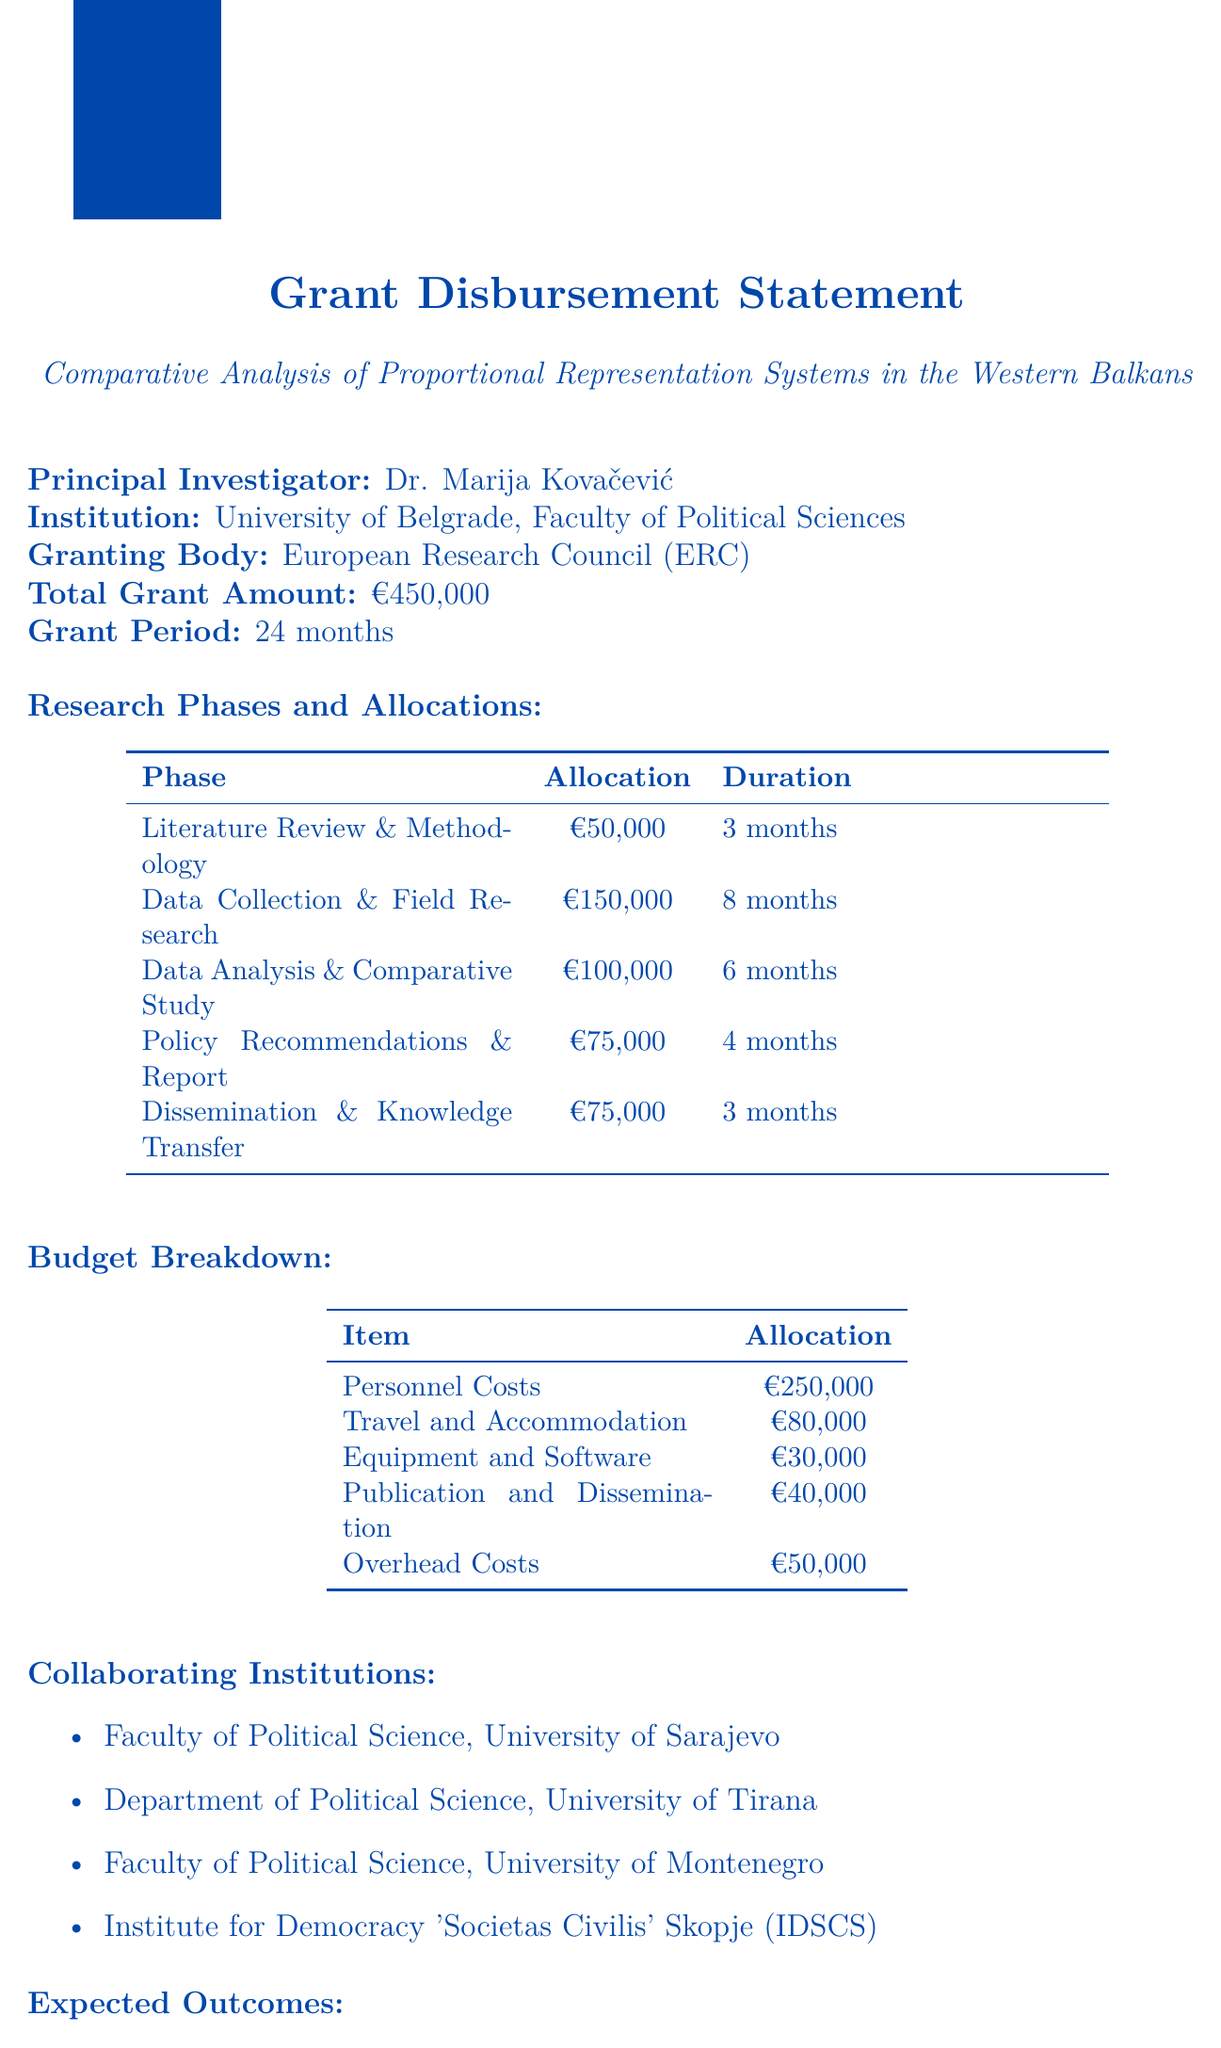What is the principal investigator's name? The principal investigator is explicitly stated in the document as Dr. Marija Kovačević.
Answer: Dr. Marija Kovačević How much is allocated for the Data Collection and Field Research phase? The specific allocation for this phase is mentioned in the document as €150,000.
Answer: €150,000 What is the total grant amount for the project? The total grant amount is clearly stated in the document as €450,000.
Answer: €450,000 How long is the grant period? The duration of the grant period is specified in the document as 24 months.
Answer: 24 months What is the duration of the Literature Review and Methodology Development phase? The duration for this phase is provided as 3 months in the document.
Answer: 3 months Which institutions are collaborating on the project? The document lists four partnering institutions, including the Faculty of Political Science, University of Sarajevo.
Answer: Faculty of Political Science, University of Sarajevo What percentage of the total grant is allocated to Personnel Costs? To find this, divide the allocation for Personnel Costs (€250,000) by the total grant (€450,000) and multiply by 100.
Answer: 55.56% What are the expected outcomes of the project? Expected outcomes are listed in the document, highlighting the creation of a comprehensive database, among other points.
Answer: Comprehensive database of electoral results and systems in the Western Balkans Which organization is the granting body? The granting body as stated in the document is the European Research Council (ERC).
Answer: European Research Council (ERC) What is the allocation for Equipment and Software? The document specifies the allocation for Equipment and Software as €30,000.
Answer: €30,000 